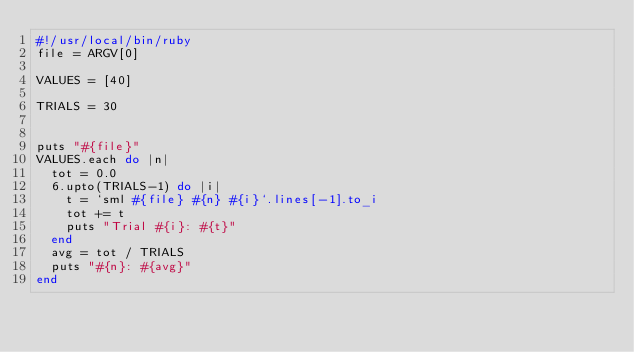<code> <loc_0><loc_0><loc_500><loc_500><_Ruby_>#!/usr/local/bin/ruby
file = ARGV[0]

VALUES = [40]

TRIALS = 30


puts "#{file}"
VALUES.each do |n|
  tot = 0.0
  6.upto(TRIALS-1) do |i|
    t = `sml #{file} #{n} #{i}`.lines[-1].to_i
    tot += t
    puts "Trial #{i}: #{t}" 
  end
  avg = tot / TRIALS
  puts "#{n}: #{avg}"
end

</code> 